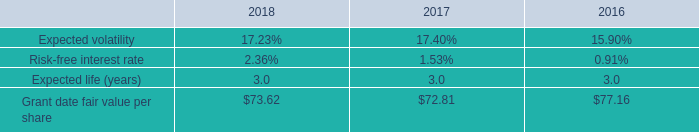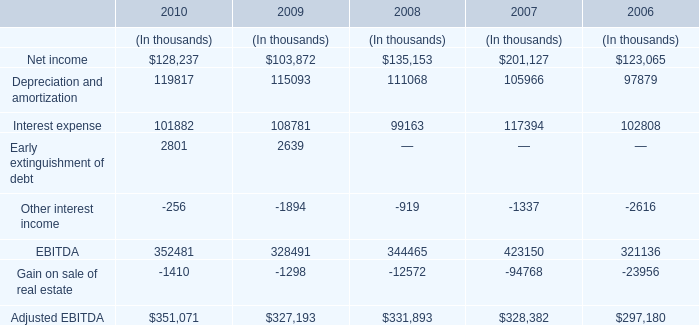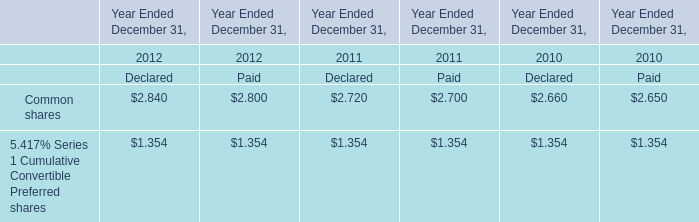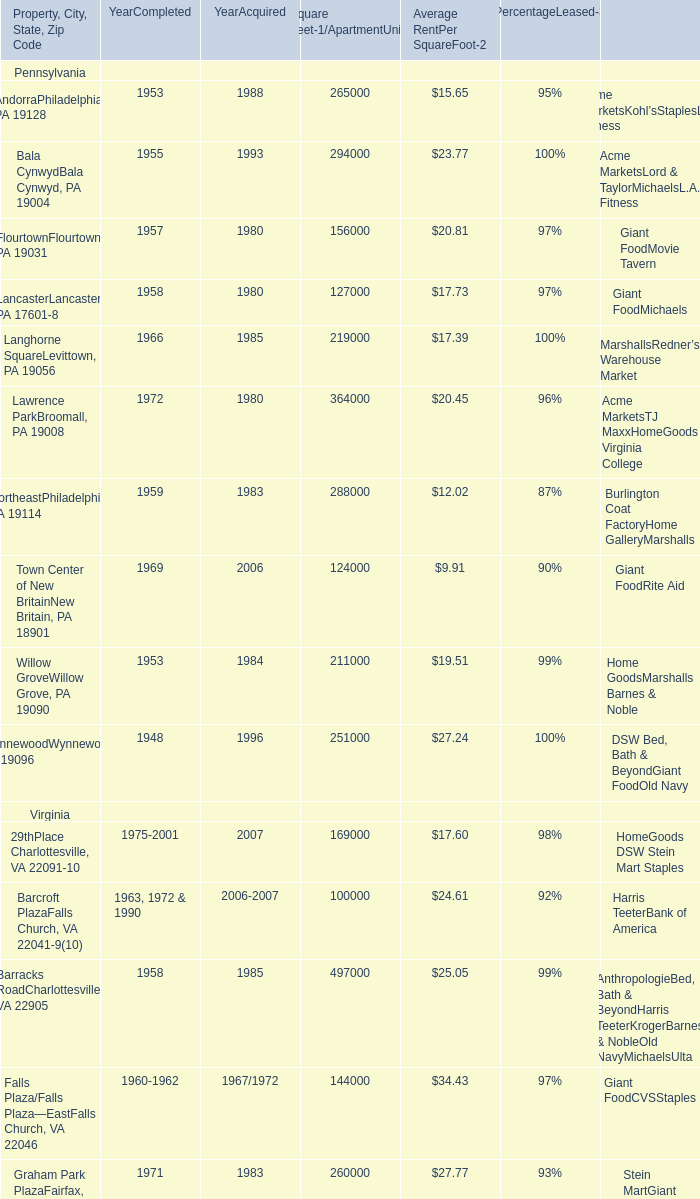What's the increasing rate of AndorraPhiladelphia, PA 19128 in 1953? 
Computations: ((23.77 - 15.65) / 15.65)
Answer: 0.51885. 